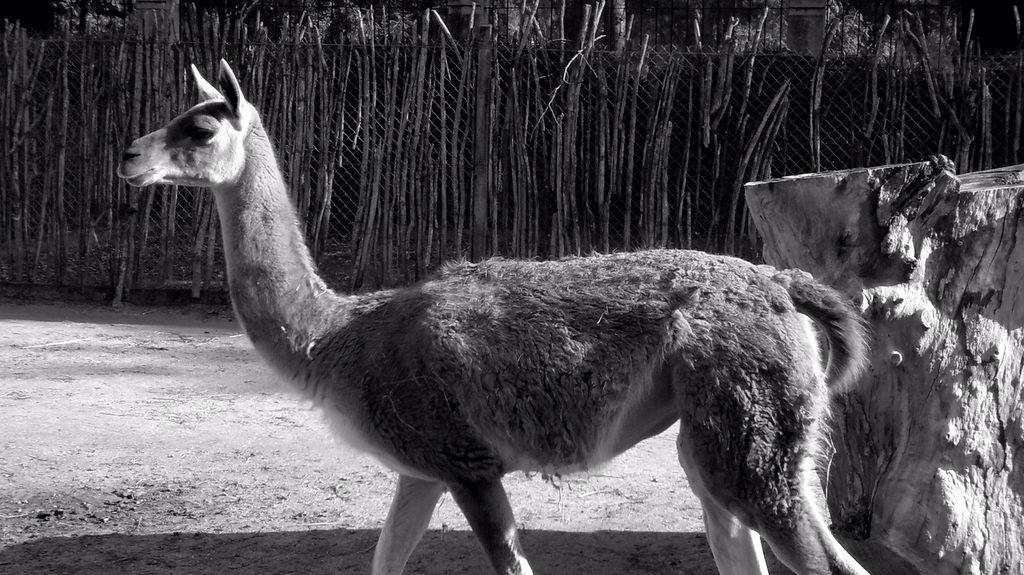What is the main object in the image? There is a tree stem in the image. Are there any living creatures in the image? Yes, there is an animal in the image. What type of structure can be seen in the image? There is a fence in the image. How would you describe the lighting in the image? The image appears to be slightly dark. What type of oatmeal is being served at the club in the image? There is no mention of oatmeal, a club, or any serving activity in the image. 